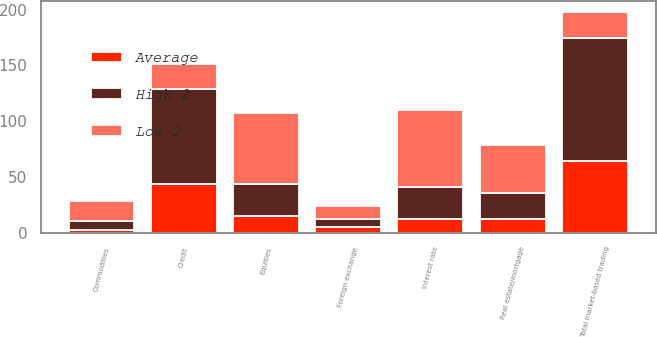Convert chart. <chart><loc_0><loc_0><loc_500><loc_500><stacked_bar_chart><ecel><fcel>Foreign exchange<fcel>Interest rate<fcel>Credit<fcel>Real estate/mortgage<fcel>Equities<fcel>Commodities<fcel>Total market-based trading<nl><fcel>High 2<fcel>7.7<fcel>28.9<fcel>84.6<fcel>22.7<fcel>28<fcel>8.2<fcel>110.7<nl><fcel>Low 2<fcel>11.7<fcel>68.3<fcel>22.7<fcel>43.1<fcel>63.9<fcel>17.7<fcel>22.7<nl><fcel>Average<fcel>5<fcel>12.4<fcel>44.1<fcel>12.8<fcel>15.5<fcel>2.4<fcel>64.1<nl></chart> 